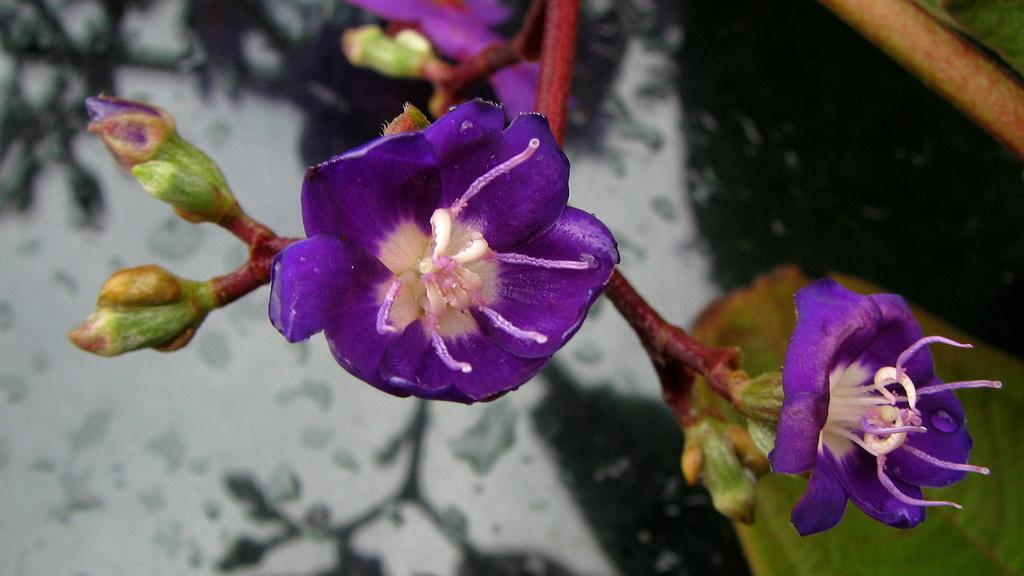What type of plant life can be seen in the image? There are flowers, buds, leaves, and stems in the image. Can you describe the different parts of the plants in the image? Yes, there are flowers, buds, leaves, and stems visible in the image. Are there any other elements related to the plants in the image? The provided facts do not mention any other elements related to the plants. What type of vegetable is growing in the mine in the image? There is no mine or vegetable present in the image; it features flowers, buds, leaves, and stems. 